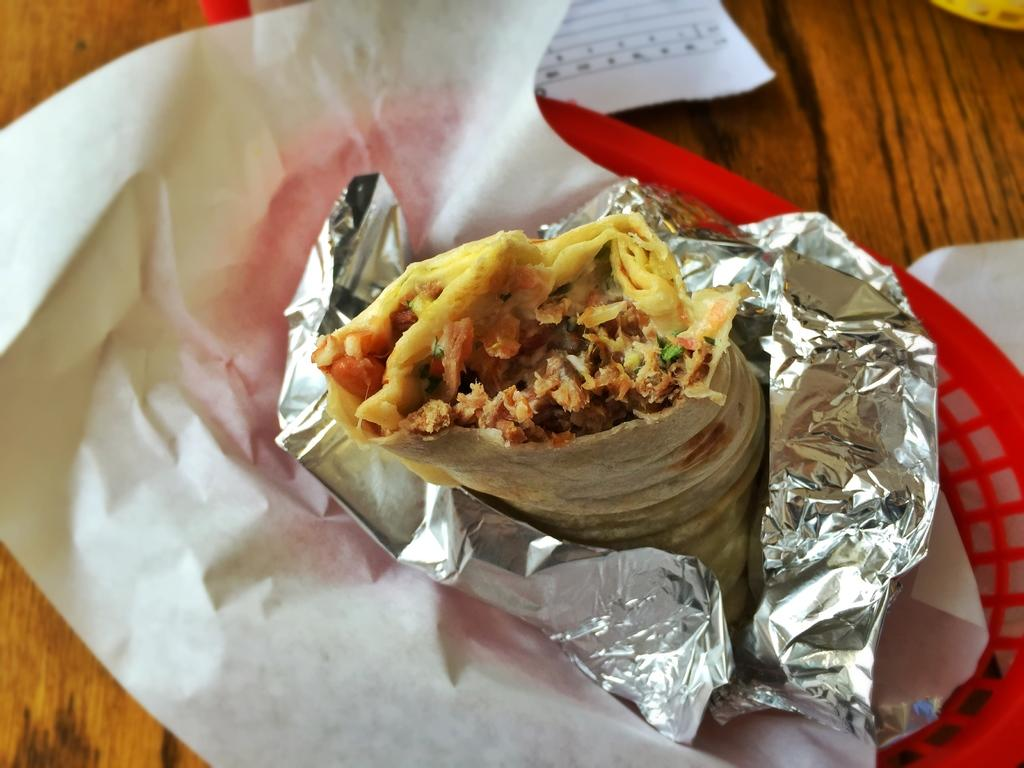What type of food is featured in the image? There is a stuffed tortilla in a wrap in the image. Where is the stuffed tortilla located? The stuffed tortilla is in a basket. On what surface is the basket placed? The basket is on a table. What else can be seen on the table? There are papers on the table. What type of test is being conducted on the queen in the image? There is no queen or test present in the image; it features a stuffed tortilla in a wrap in a basket on a table with papers. 